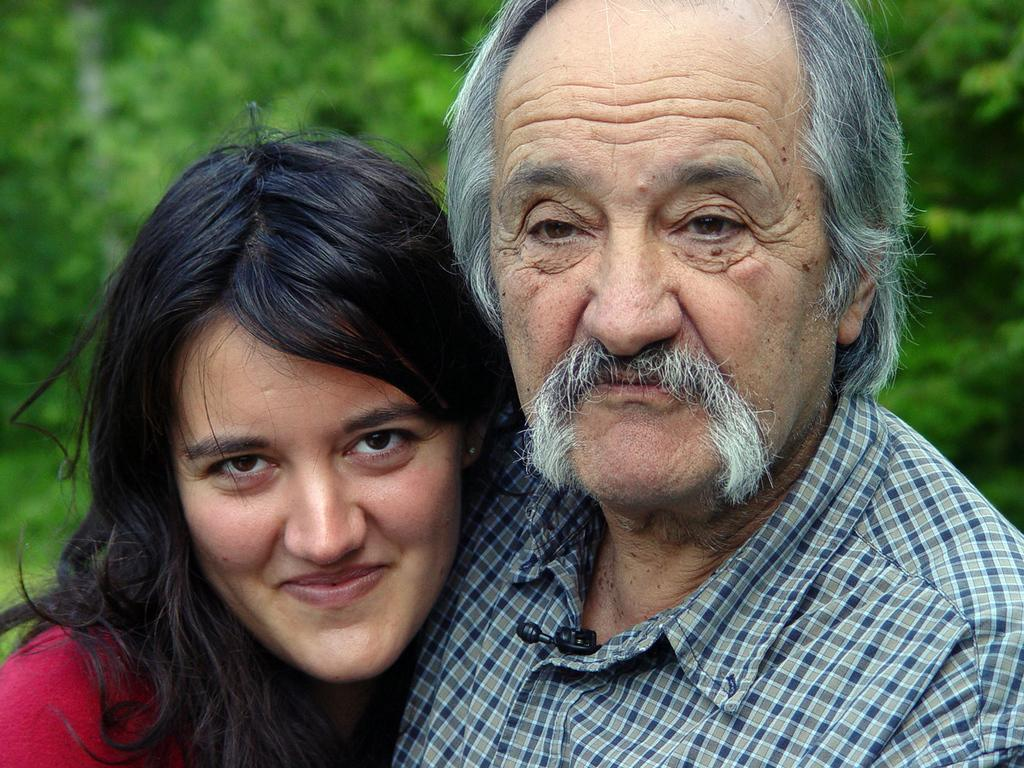How many people are in the image? There are two people in the image, a man and a woman. Where are the man and woman located in the image? The man and woman are in the center of the image. What type of shoes is the snail wearing in the image? There is no snail present in the image, and therefore no shoes to be worn by a snail. 